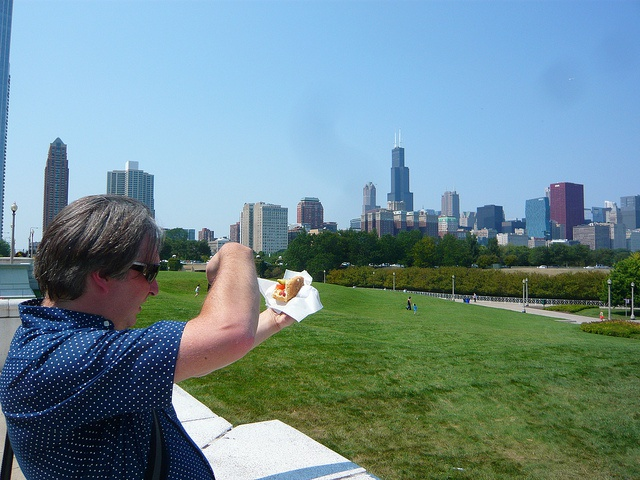Describe the objects in this image and their specific colors. I can see people in gray, black, navy, and tan tones, hot dog in gray, white, and tan tones, sandwich in gray, tan, and brown tones, people in gray, black, navy, and darkgreen tones, and people in gray, olive, and salmon tones in this image. 